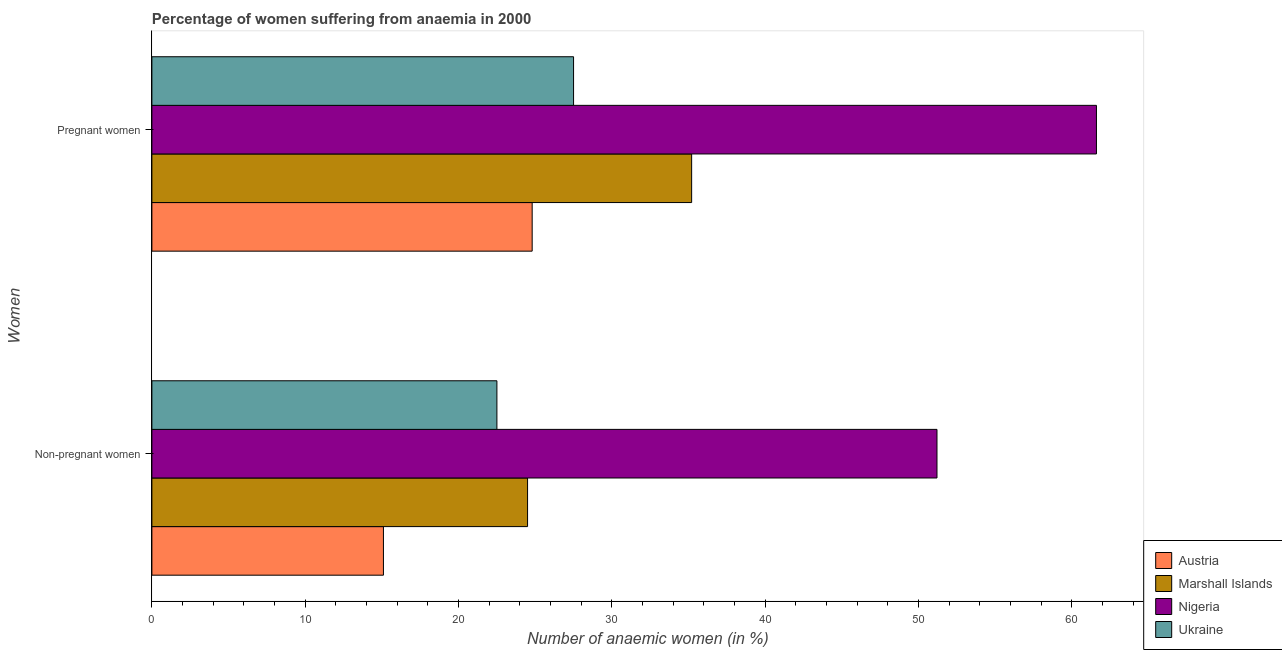How many different coloured bars are there?
Your answer should be very brief. 4. How many groups of bars are there?
Keep it short and to the point. 2. Are the number of bars per tick equal to the number of legend labels?
Provide a succinct answer. Yes. How many bars are there on the 2nd tick from the top?
Your answer should be very brief. 4. What is the label of the 1st group of bars from the top?
Keep it short and to the point. Pregnant women. What is the percentage of pregnant anaemic women in Austria?
Your answer should be compact. 24.8. Across all countries, what is the maximum percentage of pregnant anaemic women?
Offer a very short reply. 61.6. In which country was the percentage of non-pregnant anaemic women maximum?
Offer a very short reply. Nigeria. What is the total percentage of non-pregnant anaemic women in the graph?
Your answer should be very brief. 113.3. What is the difference between the percentage of pregnant anaemic women in Austria and that in Marshall Islands?
Provide a short and direct response. -10.4. What is the difference between the percentage of non-pregnant anaemic women in Marshall Islands and the percentage of pregnant anaemic women in Nigeria?
Your response must be concise. -37.1. What is the average percentage of pregnant anaemic women per country?
Your response must be concise. 37.27. What is the ratio of the percentage of non-pregnant anaemic women in Nigeria to that in Ukraine?
Your answer should be compact. 2.28. Is the percentage of pregnant anaemic women in Austria less than that in Ukraine?
Provide a short and direct response. Yes. In how many countries, is the percentage of non-pregnant anaemic women greater than the average percentage of non-pregnant anaemic women taken over all countries?
Your response must be concise. 1. What does the 4th bar from the top in Non-pregnant women represents?
Keep it short and to the point. Austria. What does the 2nd bar from the bottom in Non-pregnant women represents?
Offer a very short reply. Marshall Islands. How many bars are there?
Give a very brief answer. 8. Are all the bars in the graph horizontal?
Your response must be concise. Yes. What is the difference between two consecutive major ticks on the X-axis?
Your answer should be compact. 10. Does the graph contain grids?
Provide a short and direct response. No. Where does the legend appear in the graph?
Make the answer very short. Bottom right. How many legend labels are there?
Your answer should be very brief. 4. What is the title of the graph?
Your answer should be very brief. Percentage of women suffering from anaemia in 2000. Does "Lesotho" appear as one of the legend labels in the graph?
Offer a terse response. No. What is the label or title of the X-axis?
Provide a succinct answer. Number of anaemic women (in %). What is the label or title of the Y-axis?
Make the answer very short. Women. What is the Number of anaemic women (in %) in Nigeria in Non-pregnant women?
Provide a short and direct response. 51.2. What is the Number of anaemic women (in %) of Austria in Pregnant women?
Keep it short and to the point. 24.8. What is the Number of anaemic women (in %) in Marshall Islands in Pregnant women?
Your answer should be compact. 35.2. What is the Number of anaemic women (in %) in Nigeria in Pregnant women?
Provide a succinct answer. 61.6. What is the Number of anaemic women (in %) in Ukraine in Pregnant women?
Provide a short and direct response. 27.5. Across all Women, what is the maximum Number of anaemic women (in %) of Austria?
Keep it short and to the point. 24.8. Across all Women, what is the maximum Number of anaemic women (in %) in Marshall Islands?
Your answer should be compact. 35.2. Across all Women, what is the maximum Number of anaemic women (in %) of Nigeria?
Offer a very short reply. 61.6. Across all Women, what is the minimum Number of anaemic women (in %) of Austria?
Your answer should be very brief. 15.1. Across all Women, what is the minimum Number of anaemic women (in %) of Marshall Islands?
Offer a terse response. 24.5. Across all Women, what is the minimum Number of anaemic women (in %) of Nigeria?
Ensure brevity in your answer.  51.2. What is the total Number of anaemic women (in %) in Austria in the graph?
Your answer should be very brief. 39.9. What is the total Number of anaemic women (in %) in Marshall Islands in the graph?
Your answer should be very brief. 59.7. What is the total Number of anaemic women (in %) of Nigeria in the graph?
Provide a short and direct response. 112.8. What is the total Number of anaemic women (in %) in Ukraine in the graph?
Ensure brevity in your answer.  50. What is the difference between the Number of anaemic women (in %) in Austria in Non-pregnant women and that in Pregnant women?
Keep it short and to the point. -9.7. What is the difference between the Number of anaemic women (in %) of Marshall Islands in Non-pregnant women and that in Pregnant women?
Your response must be concise. -10.7. What is the difference between the Number of anaemic women (in %) in Ukraine in Non-pregnant women and that in Pregnant women?
Ensure brevity in your answer.  -5. What is the difference between the Number of anaemic women (in %) in Austria in Non-pregnant women and the Number of anaemic women (in %) in Marshall Islands in Pregnant women?
Provide a short and direct response. -20.1. What is the difference between the Number of anaemic women (in %) of Austria in Non-pregnant women and the Number of anaemic women (in %) of Nigeria in Pregnant women?
Make the answer very short. -46.5. What is the difference between the Number of anaemic women (in %) of Marshall Islands in Non-pregnant women and the Number of anaemic women (in %) of Nigeria in Pregnant women?
Provide a short and direct response. -37.1. What is the difference between the Number of anaemic women (in %) of Nigeria in Non-pregnant women and the Number of anaemic women (in %) of Ukraine in Pregnant women?
Keep it short and to the point. 23.7. What is the average Number of anaemic women (in %) in Austria per Women?
Your response must be concise. 19.95. What is the average Number of anaemic women (in %) in Marshall Islands per Women?
Offer a terse response. 29.85. What is the average Number of anaemic women (in %) in Nigeria per Women?
Your answer should be very brief. 56.4. What is the average Number of anaemic women (in %) of Ukraine per Women?
Your answer should be very brief. 25. What is the difference between the Number of anaemic women (in %) in Austria and Number of anaemic women (in %) in Marshall Islands in Non-pregnant women?
Offer a terse response. -9.4. What is the difference between the Number of anaemic women (in %) in Austria and Number of anaemic women (in %) in Nigeria in Non-pregnant women?
Provide a succinct answer. -36.1. What is the difference between the Number of anaemic women (in %) in Austria and Number of anaemic women (in %) in Ukraine in Non-pregnant women?
Offer a very short reply. -7.4. What is the difference between the Number of anaemic women (in %) in Marshall Islands and Number of anaemic women (in %) in Nigeria in Non-pregnant women?
Provide a succinct answer. -26.7. What is the difference between the Number of anaemic women (in %) of Nigeria and Number of anaemic women (in %) of Ukraine in Non-pregnant women?
Make the answer very short. 28.7. What is the difference between the Number of anaemic women (in %) in Austria and Number of anaemic women (in %) in Marshall Islands in Pregnant women?
Ensure brevity in your answer.  -10.4. What is the difference between the Number of anaemic women (in %) of Austria and Number of anaemic women (in %) of Nigeria in Pregnant women?
Make the answer very short. -36.8. What is the difference between the Number of anaemic women (in %) of Marshall Islands and Number of anaemic women (in %) of Nigeria in Pregnant women?
Make the answer very short. -26.4. What is the difference between the Number of anaemic women (in %) in Nigeria and Number of anaemic women (in %) in Ukraine in Pregnant women?
Ensure brevity in your answer.  34.1. What is the ratio of the Number of anaemic women (in %) in Austria in Non-pregnant women to that in Pregnant women?
Make the answer very short. 0.61. What is the ratio of the Number of anaemic women (in %) of Marshall Islands in Non-pregnant women to that in Pregnant women?
Make the answer very short. 0.7. What is the ratio of the Number of anaemic women (in %) of Nigeria in Non-pregnant women to that in Pregnant women?
Provide a succinct answer. 0.83. What is the ratio of the Number of anaemic women (in %) in Ukraine in Non-pregnant women to that in Pregnant women?
Keep it short and to the point. 0.82. What is the difference between the highest and the second highest Number of anaemic women (in %) in Austria?
Offer a very short reply. 9.7. What is the difference between the highest and the second highest Number of anaemic women (in %) in Marshall Islands?
Your answer should be compact. 10.7. What is the difference between the highest and the second highest Number of anaemic women (in %) in Nigeria?
Your answer should be very brief. 10.4. What is the difference between the highest and the lowest Number of anaemic women (in %) in Marshall Islands?
Offer a terse response. 10.7. What is the difference between the highest and the lowest Number of anaemic women (in %) of Nigeria?
Keep it short and to the point. 10.4. 